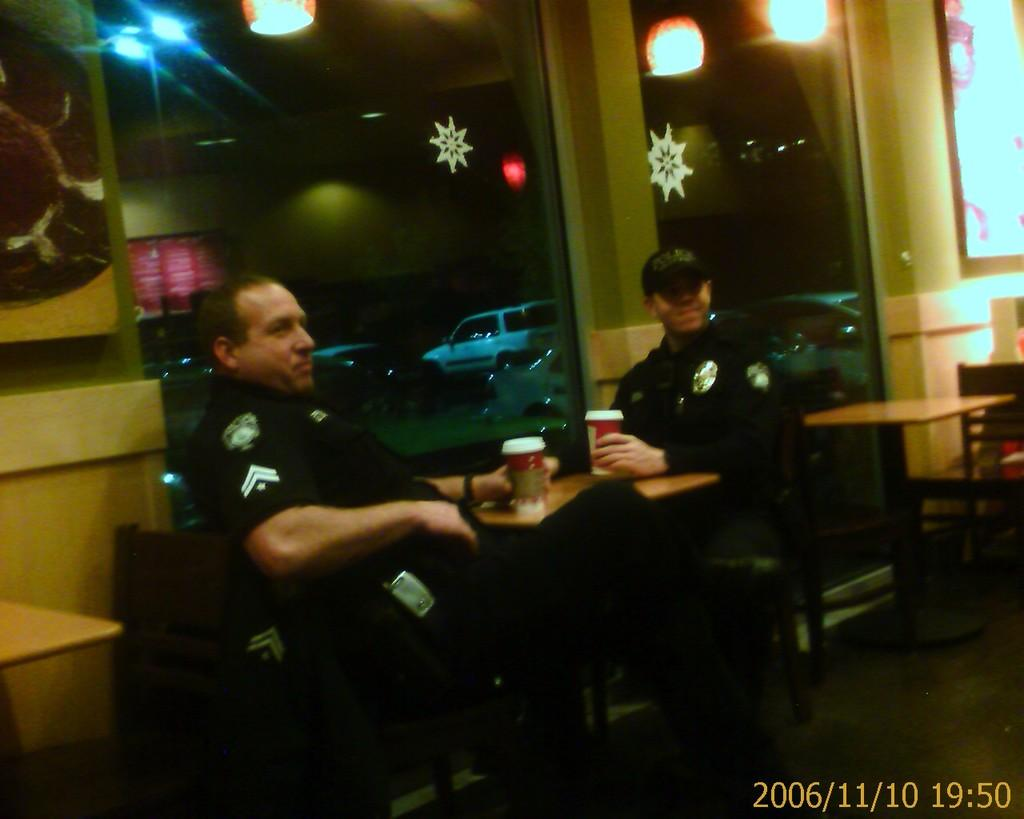What are the people in the image doing? The people in the image are sitting. What are the people holding in their hands? The people are holding glasses. What type of furniture can be seen in the image? There are tables in the image. What can be seen in the background of the image? Vehicles and lights can be seen in the background of the image. What is the structure visible in the image? There is a wall visible in the image. What type of hose is being used to play music in the image? There is no hose or music present in the image. What type of straw is being used to drink from the glasses in the image? The people in the image are holding glasses, but there is no mention of straws in the provided facts. 